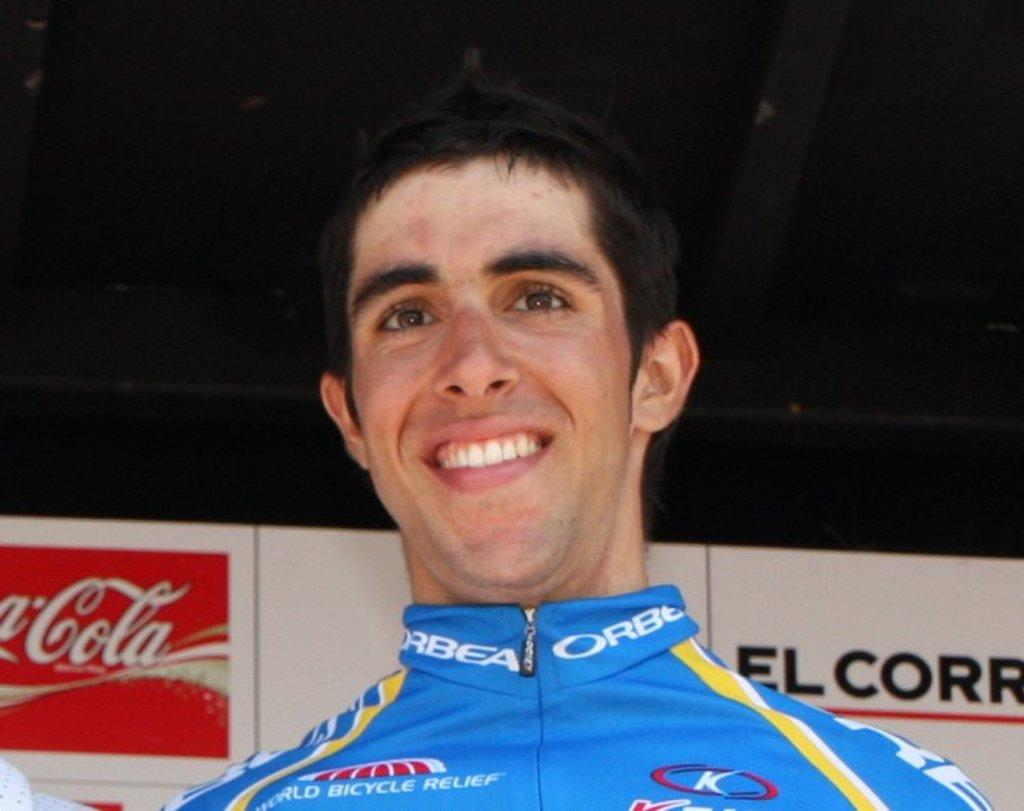Who sponsored this?
Provide a succinct answer. Coca cola. 